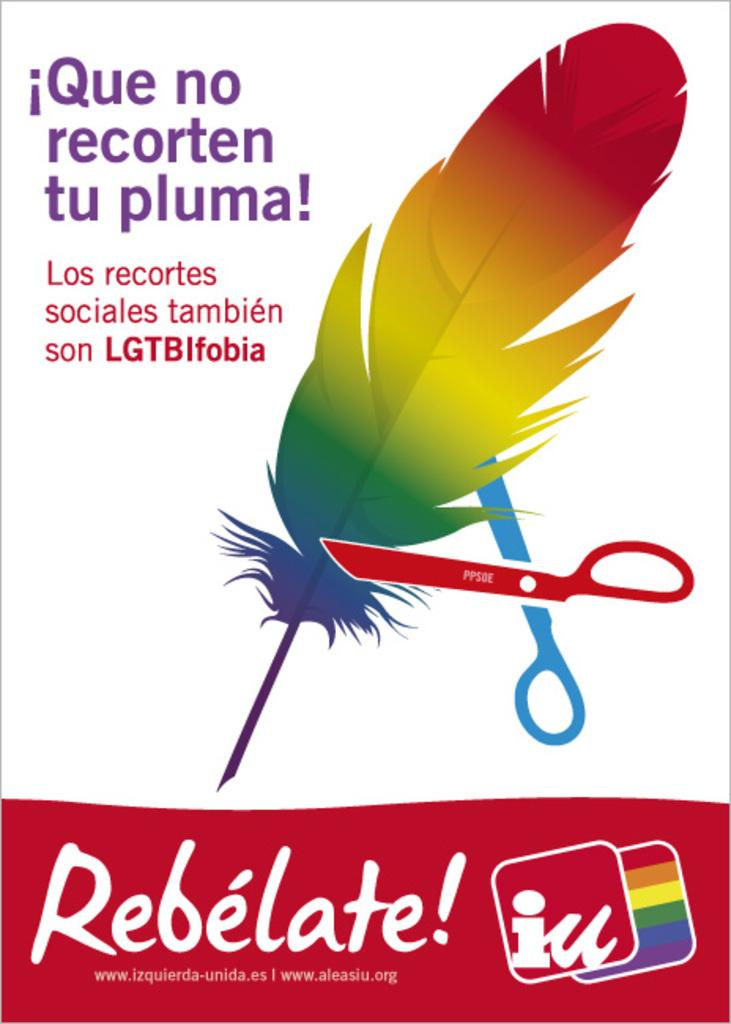<image>
Offer a succinct explanation of the picture presented. Rainbow feather being cut by blue and red scissor telling you Rebelate! 